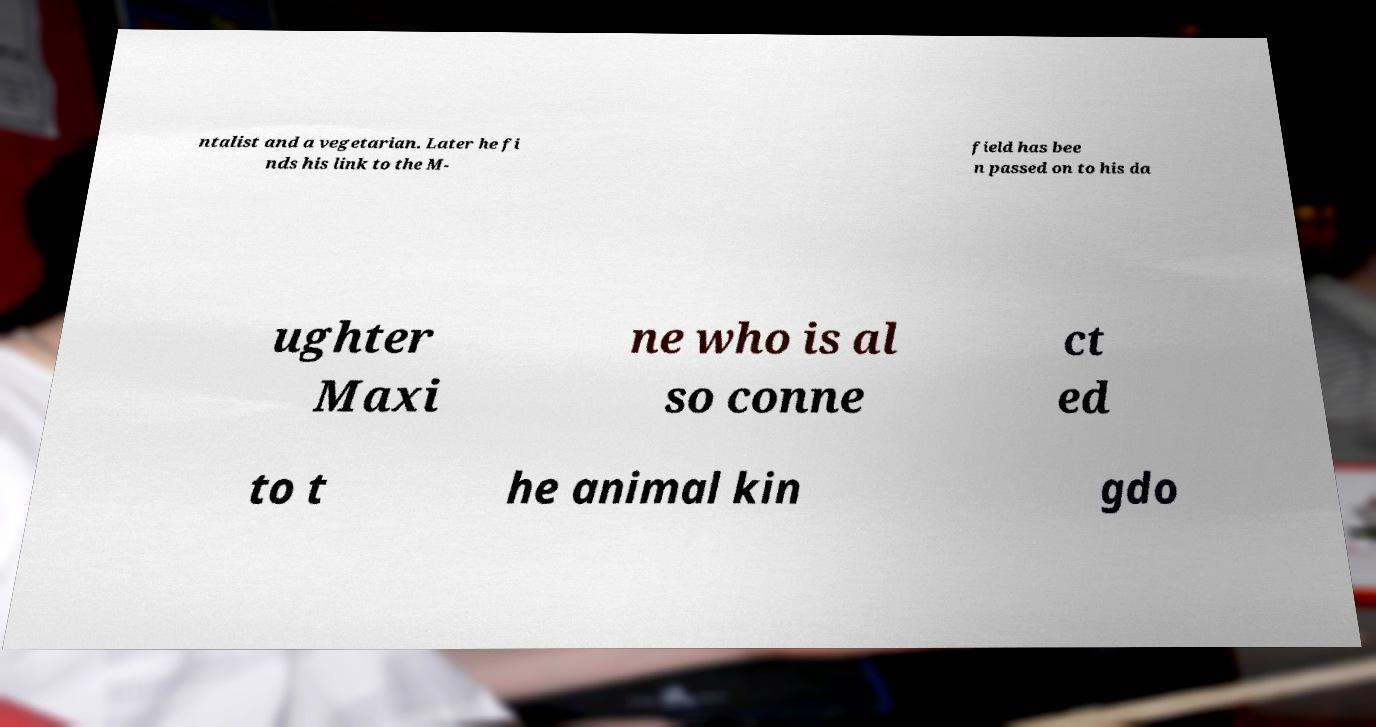Can you accurately transcribe the text from the provided image for me? ntalist and a vegetarian. Later he fi nds his link to the M- field has bee n passed on to his da ughter Maxi ne who is al so conne ct ed to t he animal kin gdo 